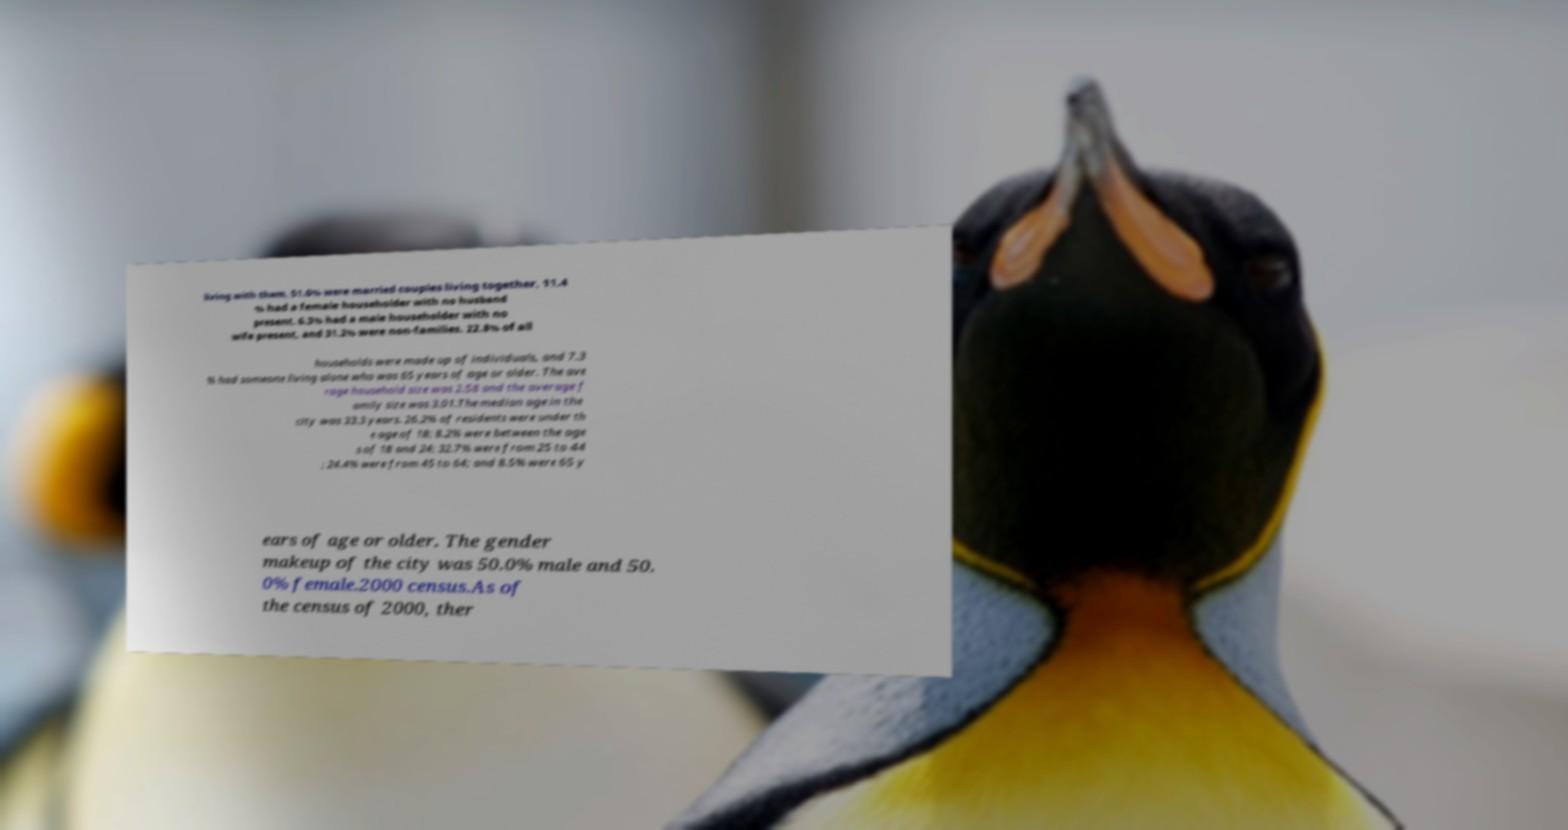Can you accurately transcribe the text from the provided image for me? living with them, 51.0% were married couples living together, 11.4 % had a female householder with no husband present, 6.3% had a male householder with no wife present, and 31.2% were non-families. 22.8% of all households were made up of individuals, and 7.3 % had someone living alone who was 65 years of age or older. The ave rage household size was 2.58 and the average f amily size was 3.01.The median age in the city was 33.3 years. 26.2% of residents were under th e age of 18; 8.2% were between the age s of 18 and 24; 32.7% were from 25 to 44 ; 24.4% were from 45 to 64; and 8.5% were 65 y ears of age or older. The gender makeup of the city was 50.0% male and 50. 0% female.2000 census.As of the census of 2000, ther 